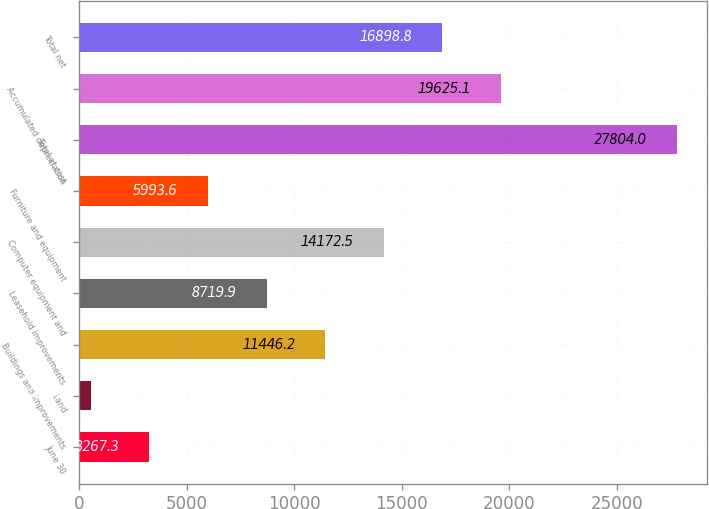Convert chart to OTSL. <chart><loc_0><loc_0><loc_500><loc_500><bar_chart><fcel>June 30<fcel>Land<fcel>Buildings and improvements<fcel>Leasehold improvements<fcel>Computer equipment and<fcel>Furniture and equipment<fcel>Total at cost<fcel>Accumulated depreciation<fcel>Total net<nl><fcel>3267.3<fcel>541<fcel>11446.2<fcel>8719.9<fcel>14172.5<fcel>5993.6<fcel>27804<fcel>19625.1<fcel>16898.8<nl></chart> 